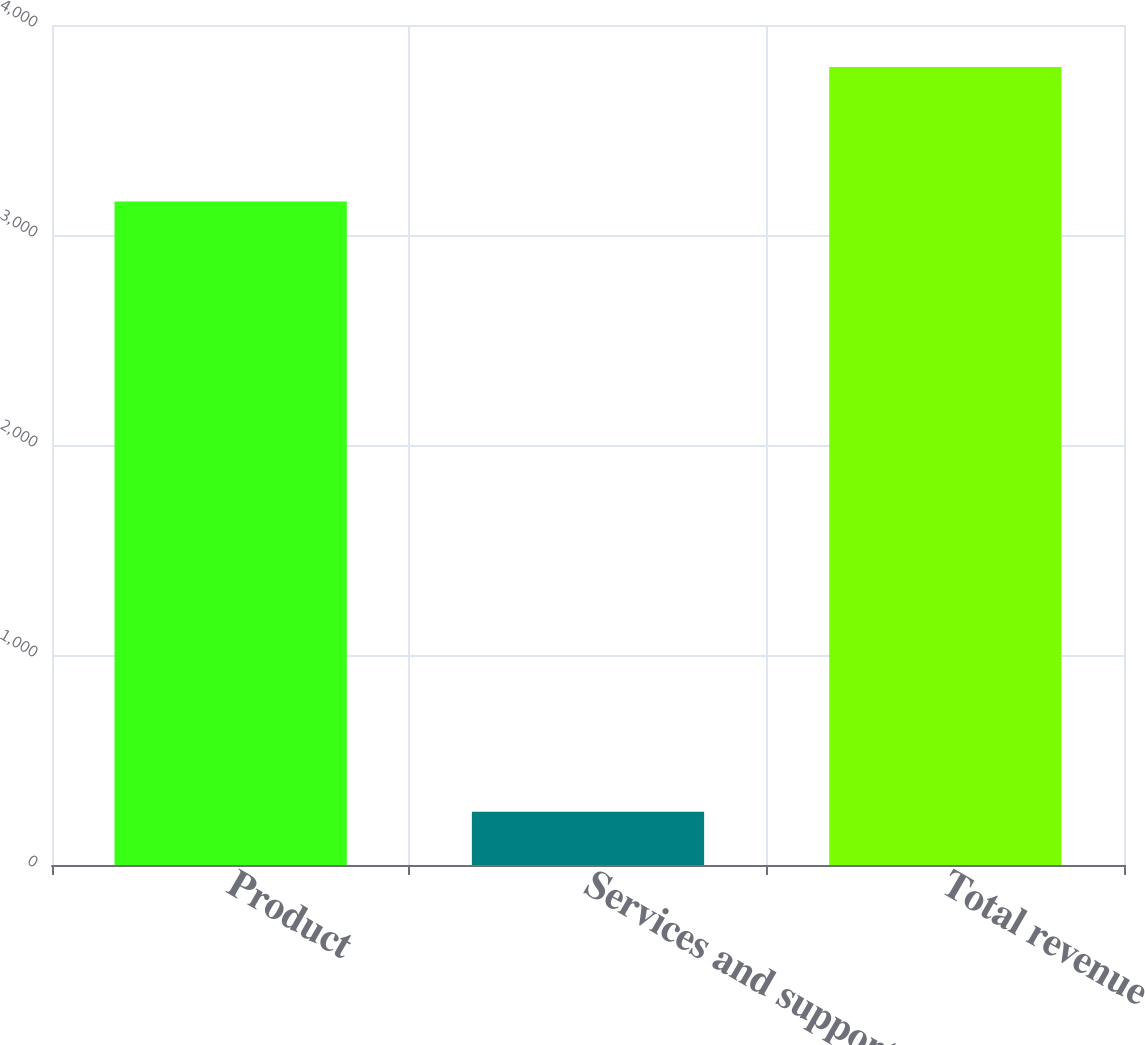Convert chart. <chart><loc_0><loc_0><loc_500><loc_500><bar_chart><fcel>Product<fcel>Services and support<fcel>Total revenue<nl><fcel>3159.2<fcel>254<fcel>3800<nl></chart> 